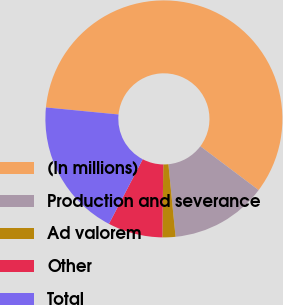Convert chart to OTSL. <chart><loc_0><loc_0><loc_500><loc_500><pie_chart><fcel>(In millions)<fcel>Production and severance<fcel>Ad valorem<fcel>Other<fcel>Total<nl><fcel>58.72%<fcel>13.17%<fcel>1.78%<fcel>7.47%<fcel>18.86%<nl></chart> 